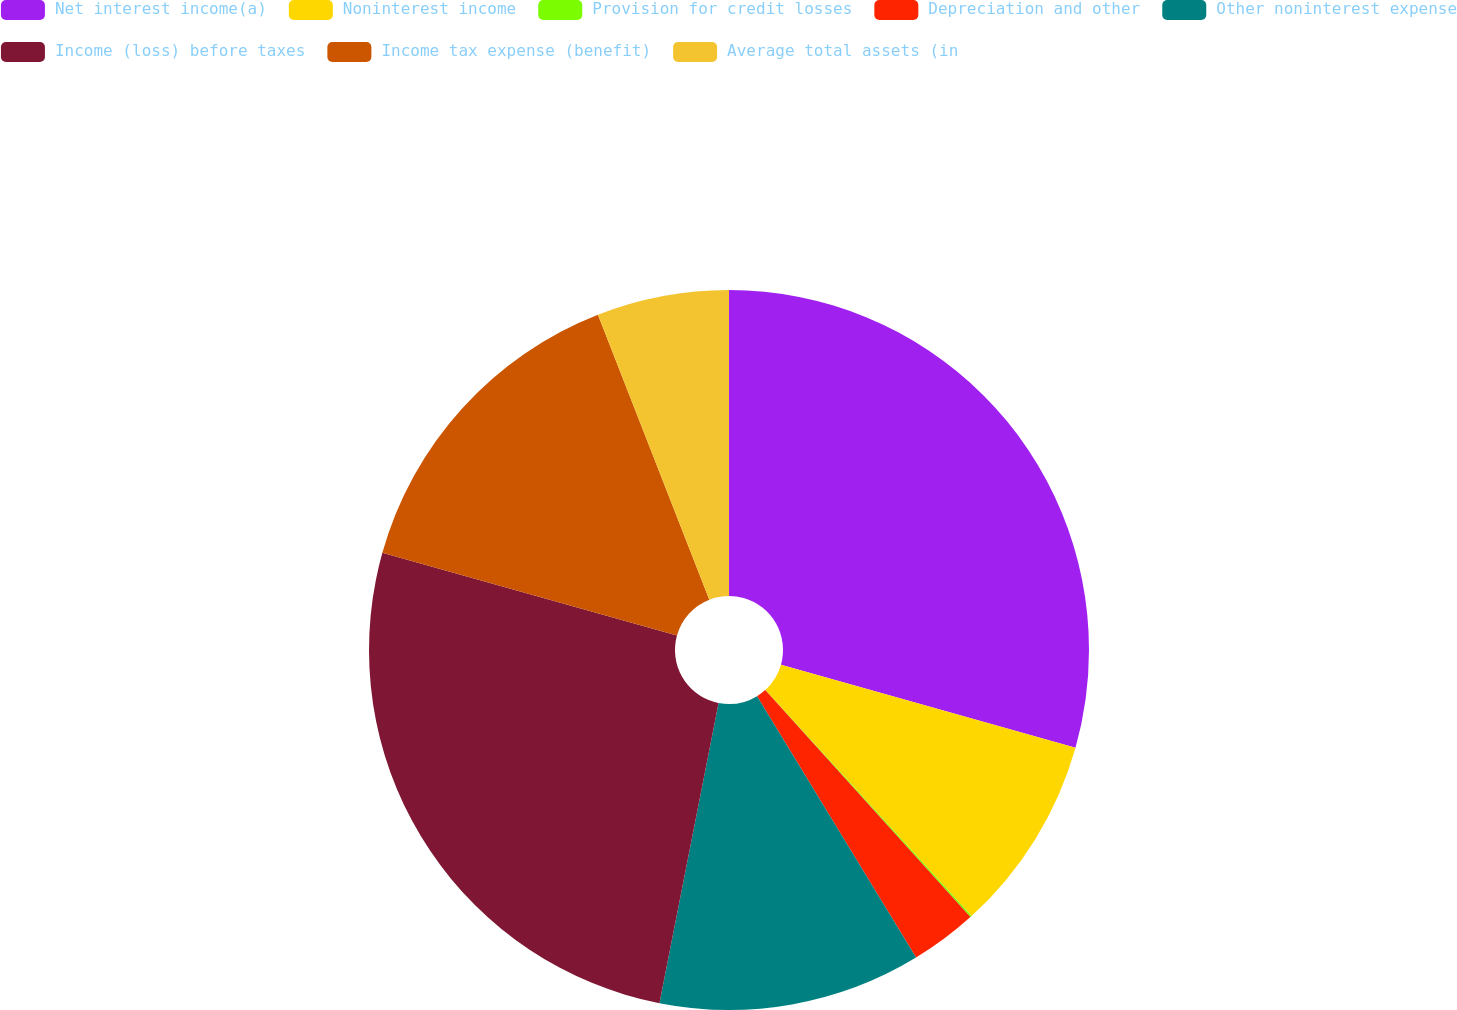Convert chart to OTSL. <chart><loc_0><loc_0><loc_500><loc_500><pie_chart><fcel>Net interest income(a)<fcel>Noninterest income<fcel>Provision for credit losses<fcel>Depreciation and other<fcel>Other noninterest expense<fcel>Income (loss) before taxes<fcel>Income tax expense (benefit)<fcel>Average total assets (in<nl><fcel>29.37%<fcel>8.86%<fcel>0.07%<fcel>3.0%<fcel>11.79%<fcel>26.25%<fcel>14.72%<fcel>5.93%<nl></chart> 